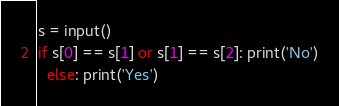Convert code to text. <code><loc_0><loc_0><loc_500><loc_500><_Python_>s = input()
if s[0] == s[1] or s[1] == s[2]: print('No')
  else: print('Yes')</code> 